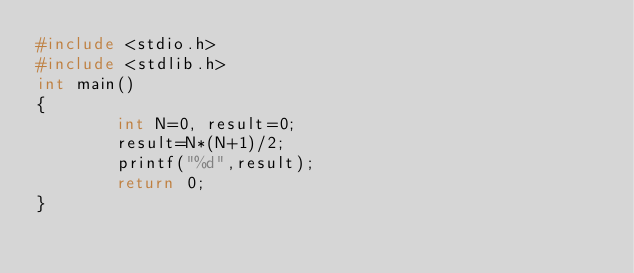<code> <loc_0><loc_0><loc_500><loc_500><_C_>#include <stdio.h>
#include <stdlib.h>
int main()
{
        int N=0, result=0;
        result=N*(N+1)/2;
        printf("%d",result);
        return 0;
}</code> 